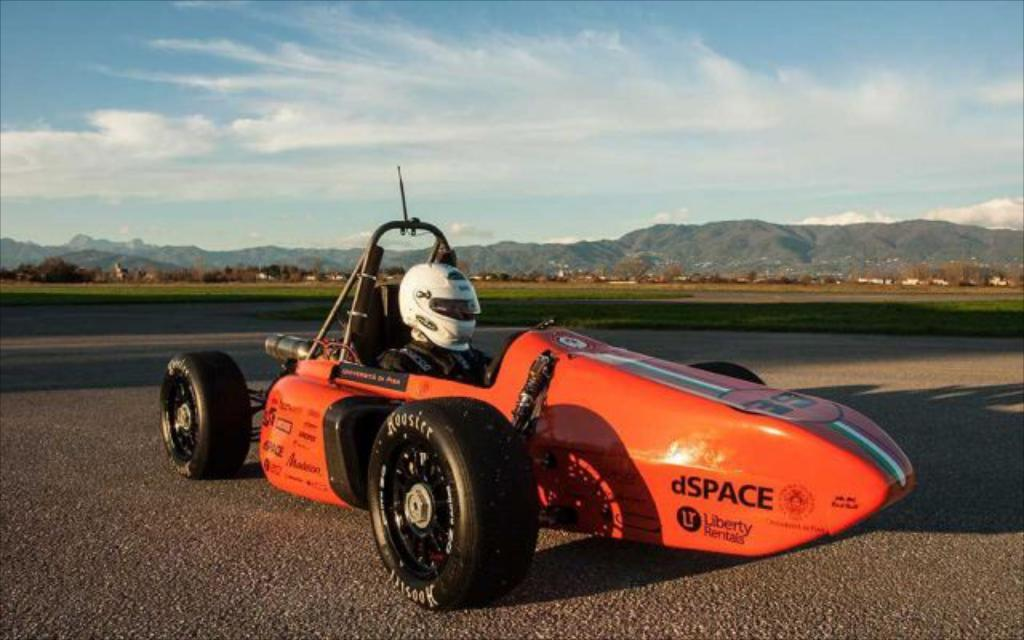What can be seen in the image? There is a person in the image, and they are sitting on a vehicle. What is the person wearing? The person is wearing a helmet. Where is the vehicle located? The vehicle is on the road. What can be seen in the background of the image? There is grass, trees, mountains, and the sky visible in the background. What is the condition of the sky in the image? Clouds are present in the sky. How many toes can be seen on the person's feet in the image? There is no visible detail of the person's feet in the image, so it is impossible to determine the number of toes. 